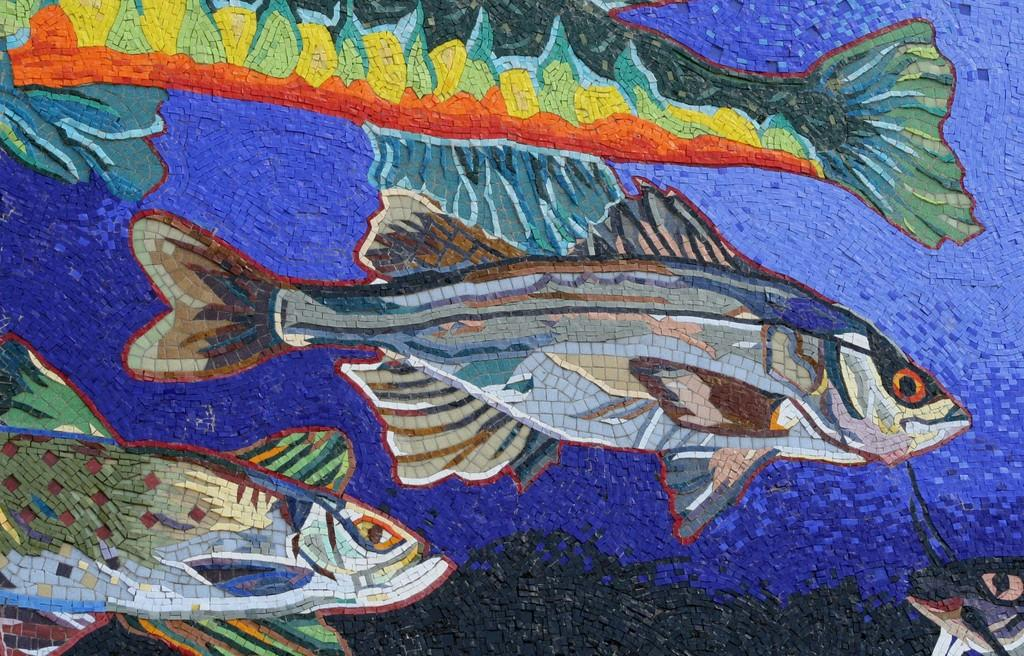What type of artwork is depicted in the image? The image appears to be a painting. What animals are featured in the painting? There are fishes in the image. What type of coat is the guide wearing during the dinner scene in the image? There is no dinner scene, guide, or coat present in the image; it is a painting featuring fishes. 